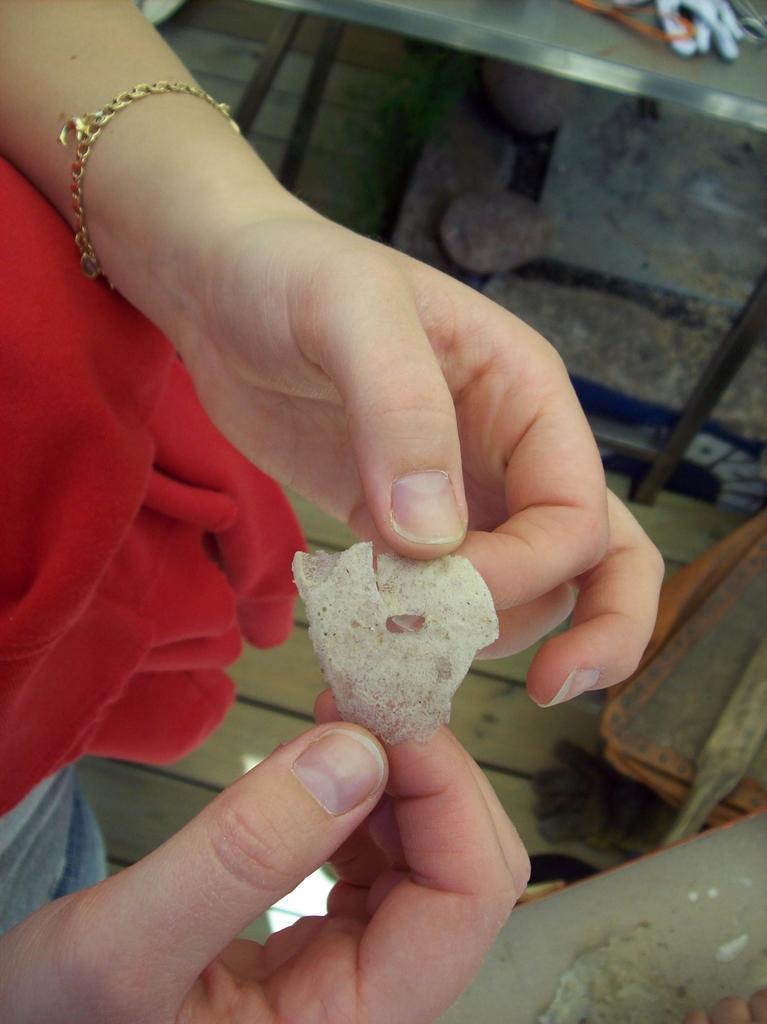How would you summarize this image in a sentence or two? In the picture there is a person holding some item with the both hands and below the hands there is wooden floor and two tables. 